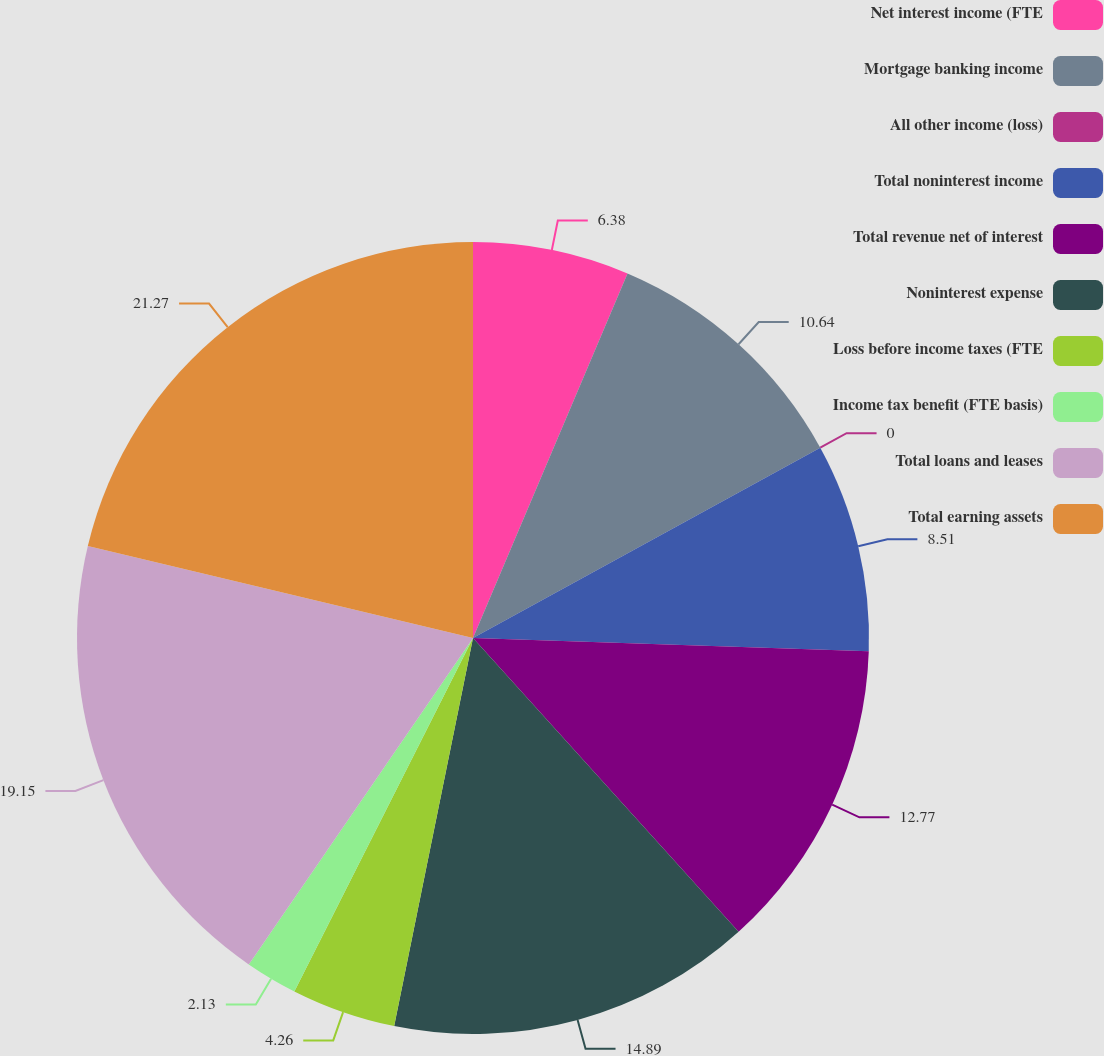<chart> <loc_0><loc_0><loc_500><loc_500><pie_chart><fcel>Net interest income (FTE<fcel>Mortgage banking income<fcel>All other income (loss)<fcel>Total noninterest income<fcel>Total revenue net of interest<fcel>Noninterest expense<fcel>Loss before income taxes (FTE<fcel>Income tax benefit (FTE basis)<fcel>Total loans and leases<fcel>Total earning assets<nl><fcel>6.38%<fcel>10.64%<fcel>0.0%<fcel>8.51%<fcel>12.77%<fcel>14.89%<fcel>4.26%<fcel>2.13%<fcel>19.15%<fcel>21.27%<nl></chart> 